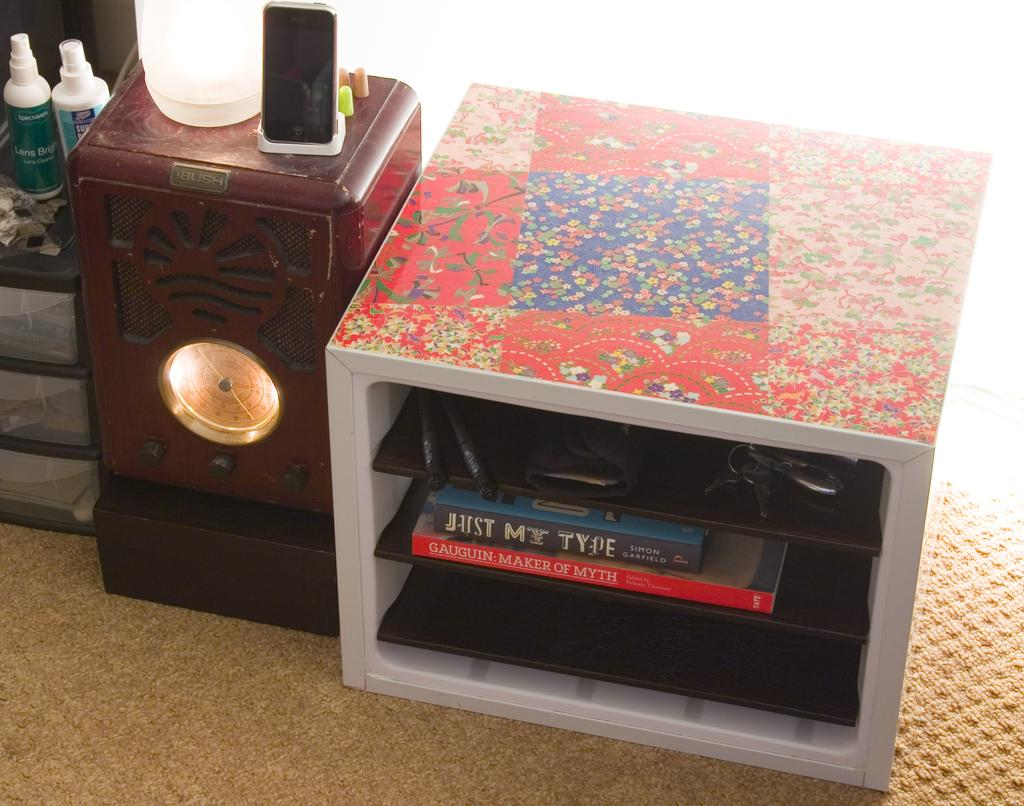<image>
Give a short and clear explanation of the subsequent image. The book with the blue cover is titled Just My Type 